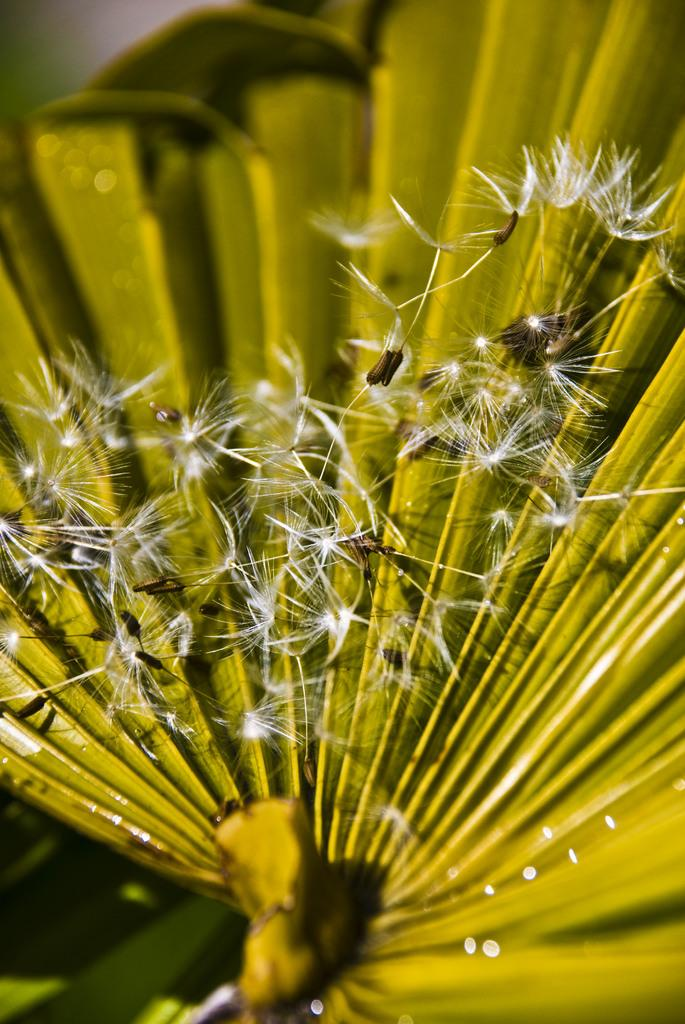What type of plant is visible in the image? There are dandelions in the image. What other plant element can be seen in the image? There is a green leaf in the image. How would you describe the background of the image? The backdrop is blurred. What type of bubble can be seen in the image? There is no bubble present in the image. Why is the person wearing a sweater in the image? There is no person wearing a sweater in the image; it only features dandelions and a green leaf. 